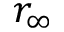<formula> <loc_0><loc_0><loc_500><loc_500>r _ { \infty }</formula> 